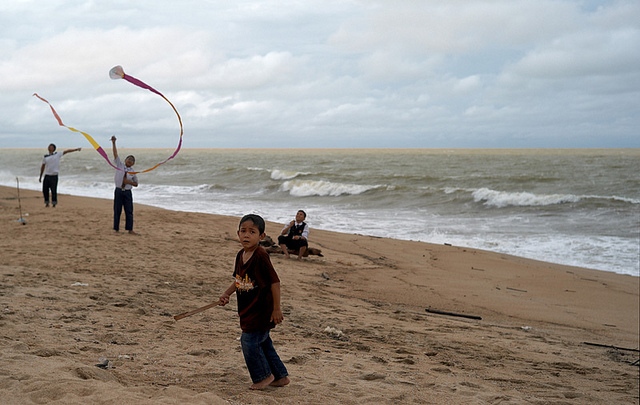<image>How many footsteps are in the sand? It is unknown how many footsteps are in the sand. The number could vary greatly. How many footsteps are in the sand? I don't know how many footsteps are in the sand. It can be many, over 100, or even unknown. 